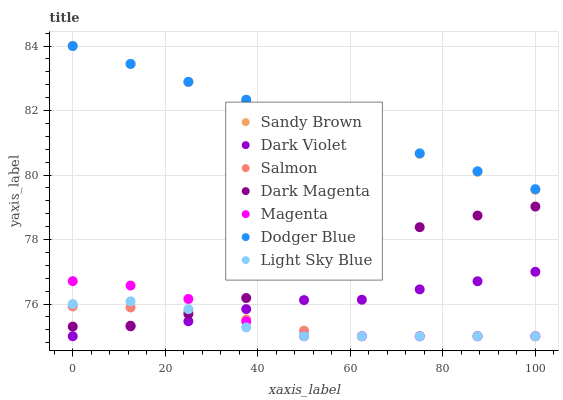Does Light Sky Blue have the minimum area under the curve?
Answer yes or no. Yes. Does Dodger Blue have the maximum area under the curve?
Answer yes or no. Yes. Does Salmon have the minimum area under the curve?
Answer yes or no. No. Does Salmon have the maximum area under the curve?
Answer yes or no. No. Is Sandy Brown the smoothest?
Answer yes or no. Yes. Is Dark Magenta the roughest?
Answer yes or no. Yes. Is Salmon the smoothest?
Answer yes or no. No. Is Salmon the roughest?
Answer yes or no. No. Does Salmon have the lowest value?
Answer yes or no. Yes. Does Dodger Blue have the lowest value?
Answer yes or no. No. Does Sandy Brown have the highest value?
Answer yes or no. Yes. Does Dark Violet have the highest value?
Answer yes or no. No. Is Magenta less than Sandy Brown?
Answer yes or no. Yes. Is Sandy Brown greater than Magenta?
Answer yes or no. Yes. Does Dark Violet intersect Magenta?
Answer yes or no. Yes. Is Dark Violet less than Magenta?
Answer yes or no. No. Is Dark Violet greater than Magenta?
Answer yes or no. No. Does Magenta intersect Sandy Brown?
Answer yes or no. No. 